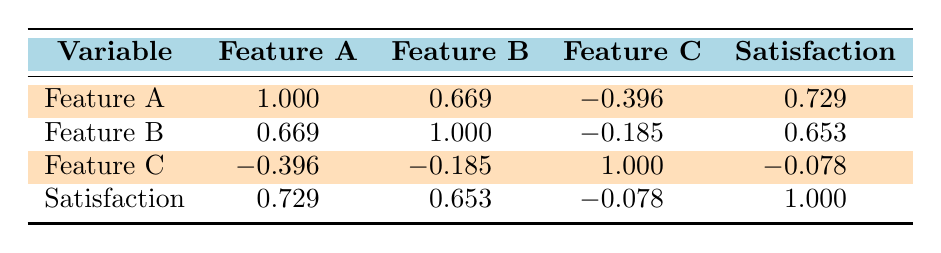What is the correlation between Feature A and customer satisfaction? The table shows a correlation coefficient of 0.729 between Feature A and customer satisfaction. This indicates a strong positive relationship, meaning higher usage of Feature A is associated with higher customer satisfaction scores.
Answer: 0.729 What is the correlation between Feature C and customer satisfaction? The correlation coefficient between Feature C and customer satisfaction is -0.078, which suggests there is almost no linear relationship between the two variables. Thus, changes in Feature C usage do not significantly affect customer satisfaction.
Answer: -0.078 Is the correlation between Feature B and Feature C positive or negative? According to the table, the correlation coefficient between Feature B and Feature C is -0.185. Since this value is negative, it indicates that there is a slight negative correlation, meaning as usage of one feature increases, the other tends to decrease.
Answer: Negative Which feature shows the strongest positive correlation with customer satisfaction? The table indicates that Feature A has the highest correlation coefficient with customer satisfaction, at 0.729. This suggests that customers who use Feature A more tend to report higher satisfaction.
Answer: Feature A What is the average correlation between all features and customer satisfaction? To calculate the average correlation, we take the correlation coefficients of Feature A (0.729), Feature B (0.653), and Feature C (-0.078), sum them (0.729 + 0.653 - 0.078 = 1.304) and divide by 3. The average is 1.304 / 3 = approximately 0.435.
Answer: 0.435 Does increasing the usage of Feature B lead to higher customer satisfaction? The correlation coefficient for Feature B and customer satisfaction is 0.653, which indicates a positive correlation. Therefore, as customers use Feature B more frequently, their satisfaction levels tend to increase as well.
Answer: Yes What is the correlation between Feature A usage and Feature C usage? The table shows a correlation coefficient of -0.396 between Feature A and Feature C, indicating a moderate negative correlation. This suggests that higher usage of Feature A may be associated with lower usage of Feature C.
Answer: -0.396 What would the correlation score be if Feature C had zero usage? Since the correlation score measures how one variable relates to another, if Feature C had zero usage, it would likely not significantly change the correlation scores already listed unless other data points change dramatically. However, it cannot be determined without additional data.
Answer: Indeterminate How does Feature A usage compare to Feature B usage in terms of correlation with customer satisfaction? Feature A has a correlation coefficient of 0.729 with customer satisfaction, while Feature B has a coefficient of 0.653. This indicates that Feature A usage has a stronger positive correlation with customer satisfaction than Feature B usage.
Answer: Feature A is stronger 